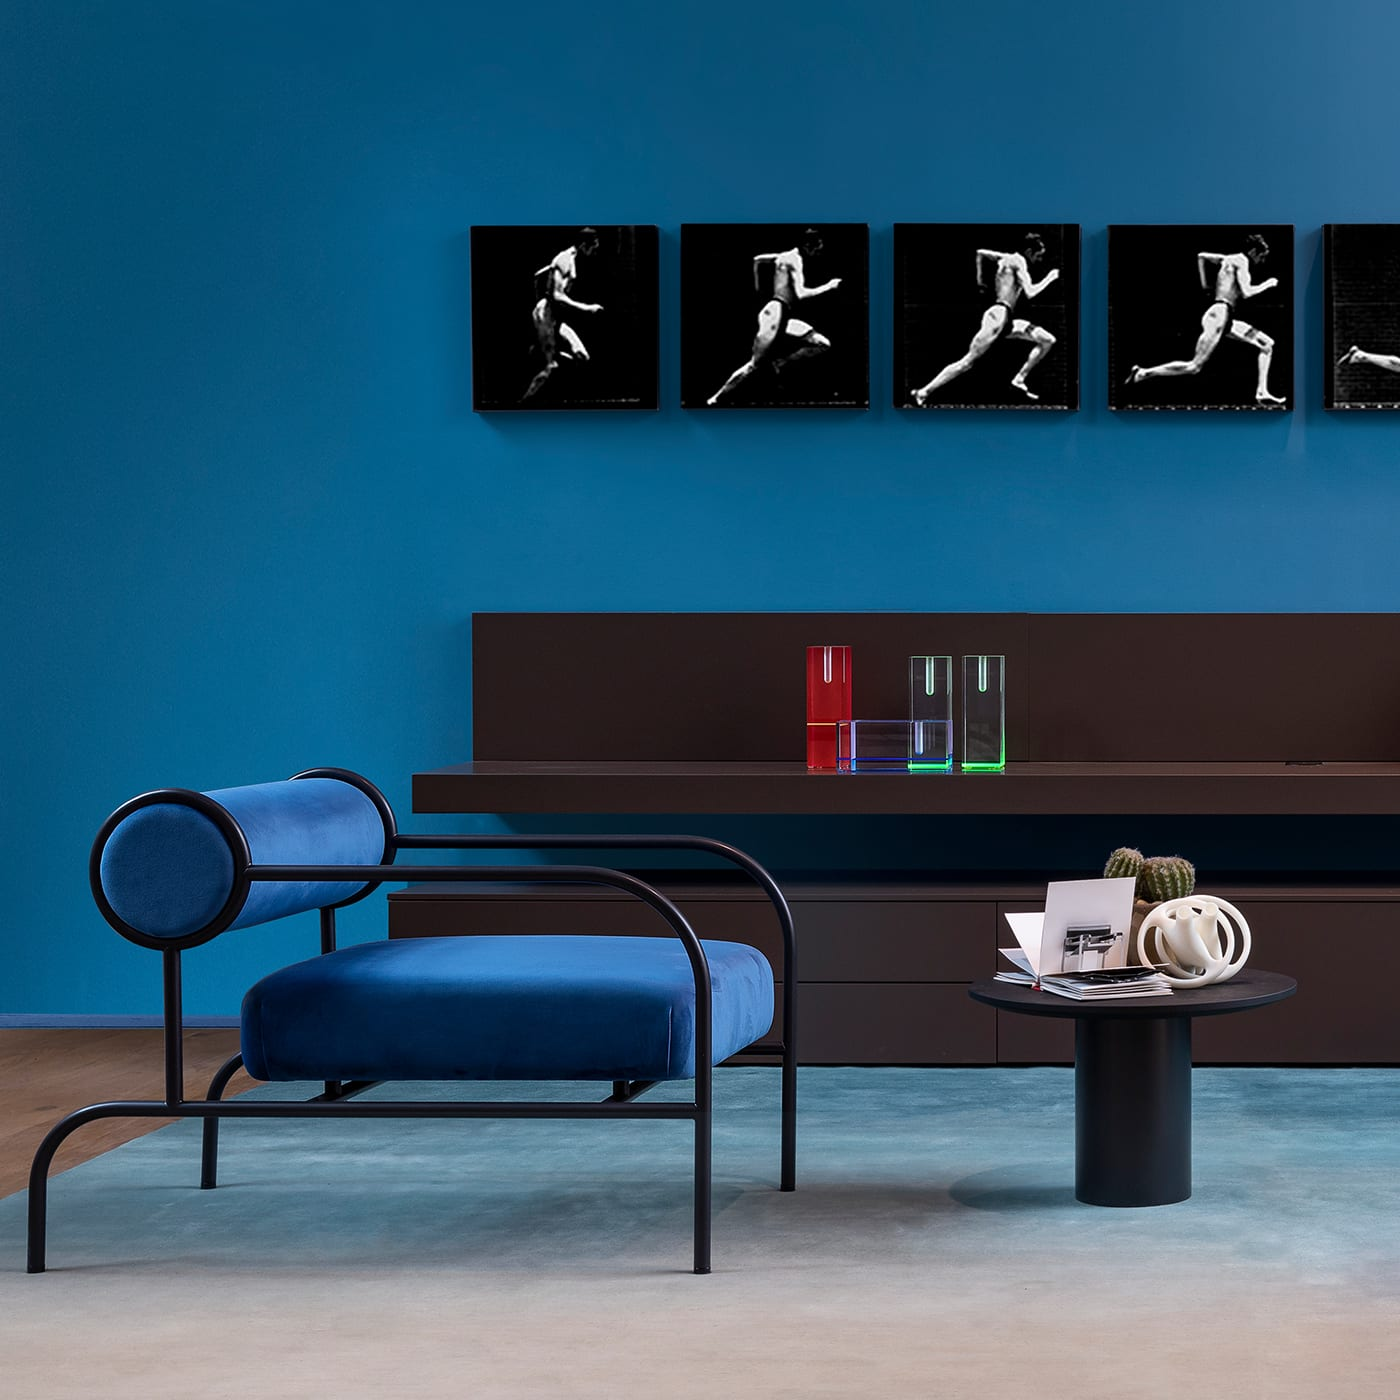What different colors are present in the room? The room features a rich palette including the deep blue of the seating, a dark brown tone on the storage unit, vibrant red, green, and blue hues showcased within the decorative glassware, and the contrasting grey flooring. 